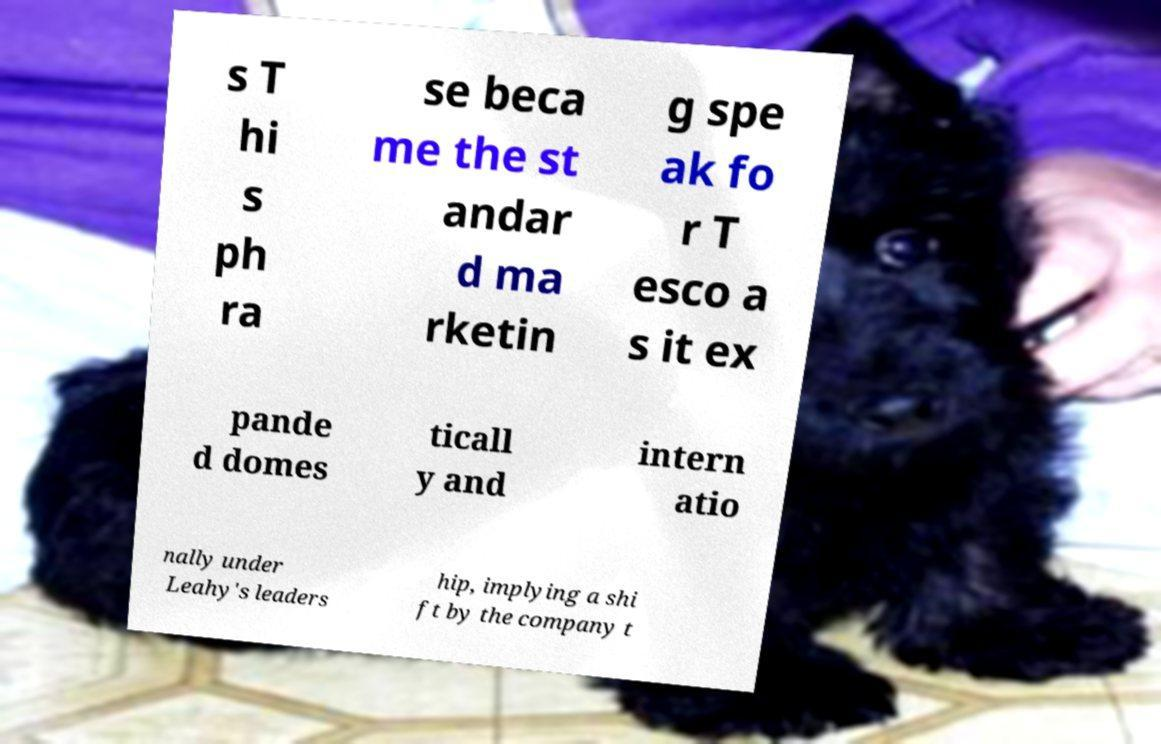Please read and relay the text visible in this image. What does it say? s T hi s ph ra se beca me the st andar d ma rketin g spe ak fo r T esco a s it ex pande d domes ticall y and intern atio nally under Leahy's leaders hip, implying a shi ft by the company t 